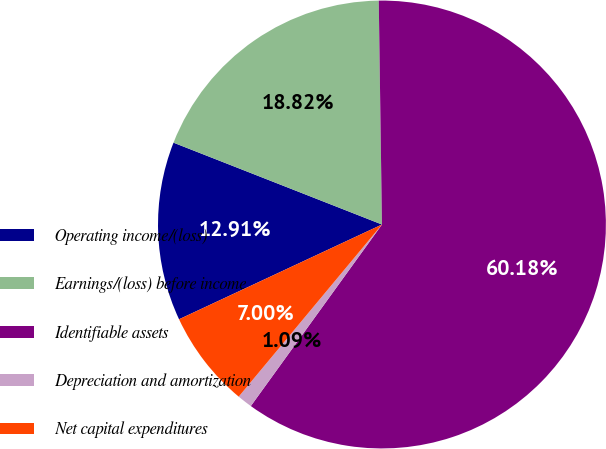Convert chart. <chart><loc_0><loc_0><loc_500><loc_500><pie_chart><fcel>Operating income/(loss)<fcel>Earnings/(loss) before income<fcel>Identifiable assets<fcel>Depreciation and amortization<fcel>Net capital expenditures<nl><fcel>12.91%<fcel>18.82%<fcel>60.19%<fcel>1.09%<fcel>7.0%<nl></chart> 